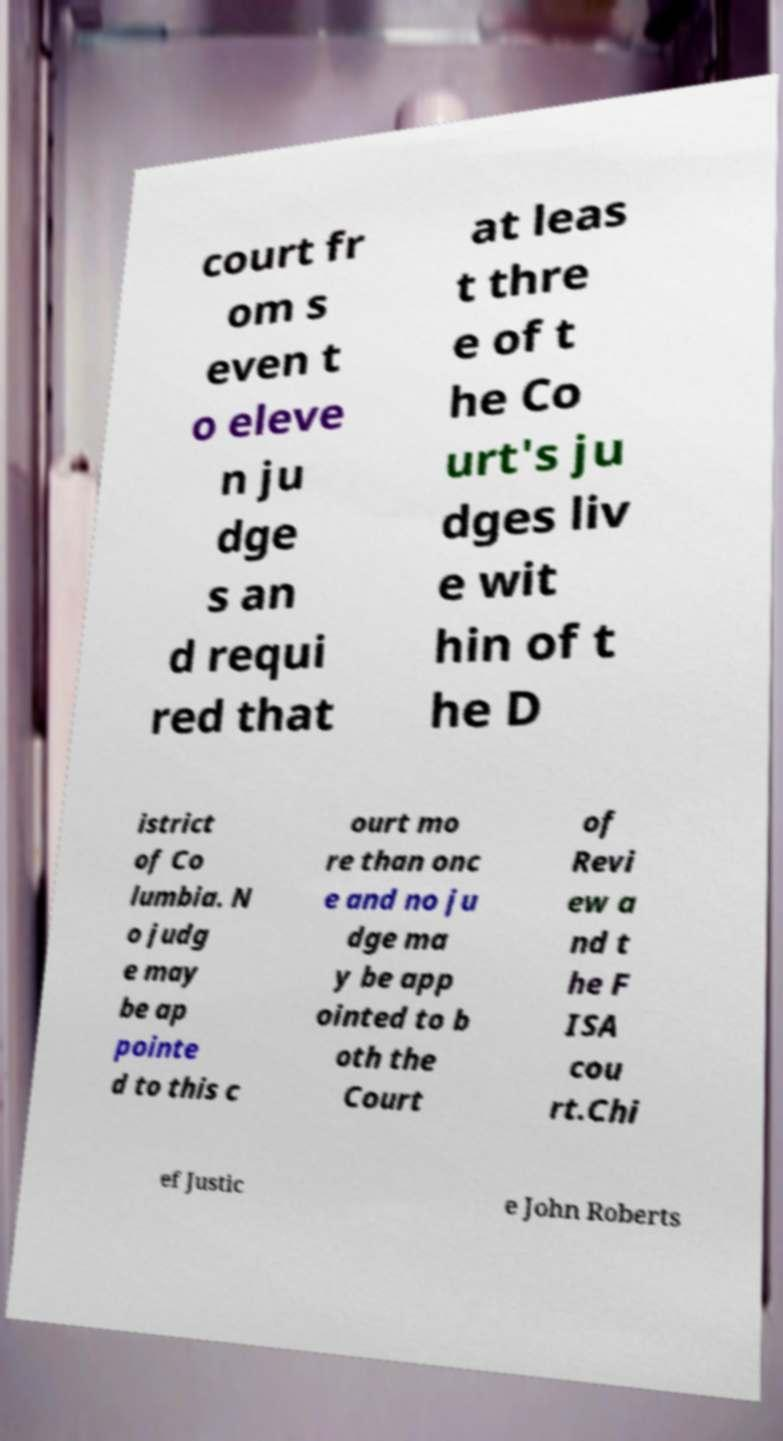There's text embedded in this image that I need extracted. Can you transcribe it verbatim? court fr om s even t o eleve n ju dge s an d requi red that at leas t thre e of t he Co urt's ju dges liv e wit hin of t he D istrict of Co lumbia. N o judg e may be ap pointe d to this c ourt mo re than onc e and no ju dge ma y be app ointed to b oth the Court of Revi ew a nd t he F ISA cou rt.Chi ef Justic e John Roberts 